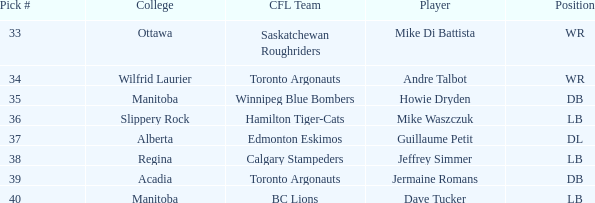What Player has a College that is alberta? Guillaume Petit. 